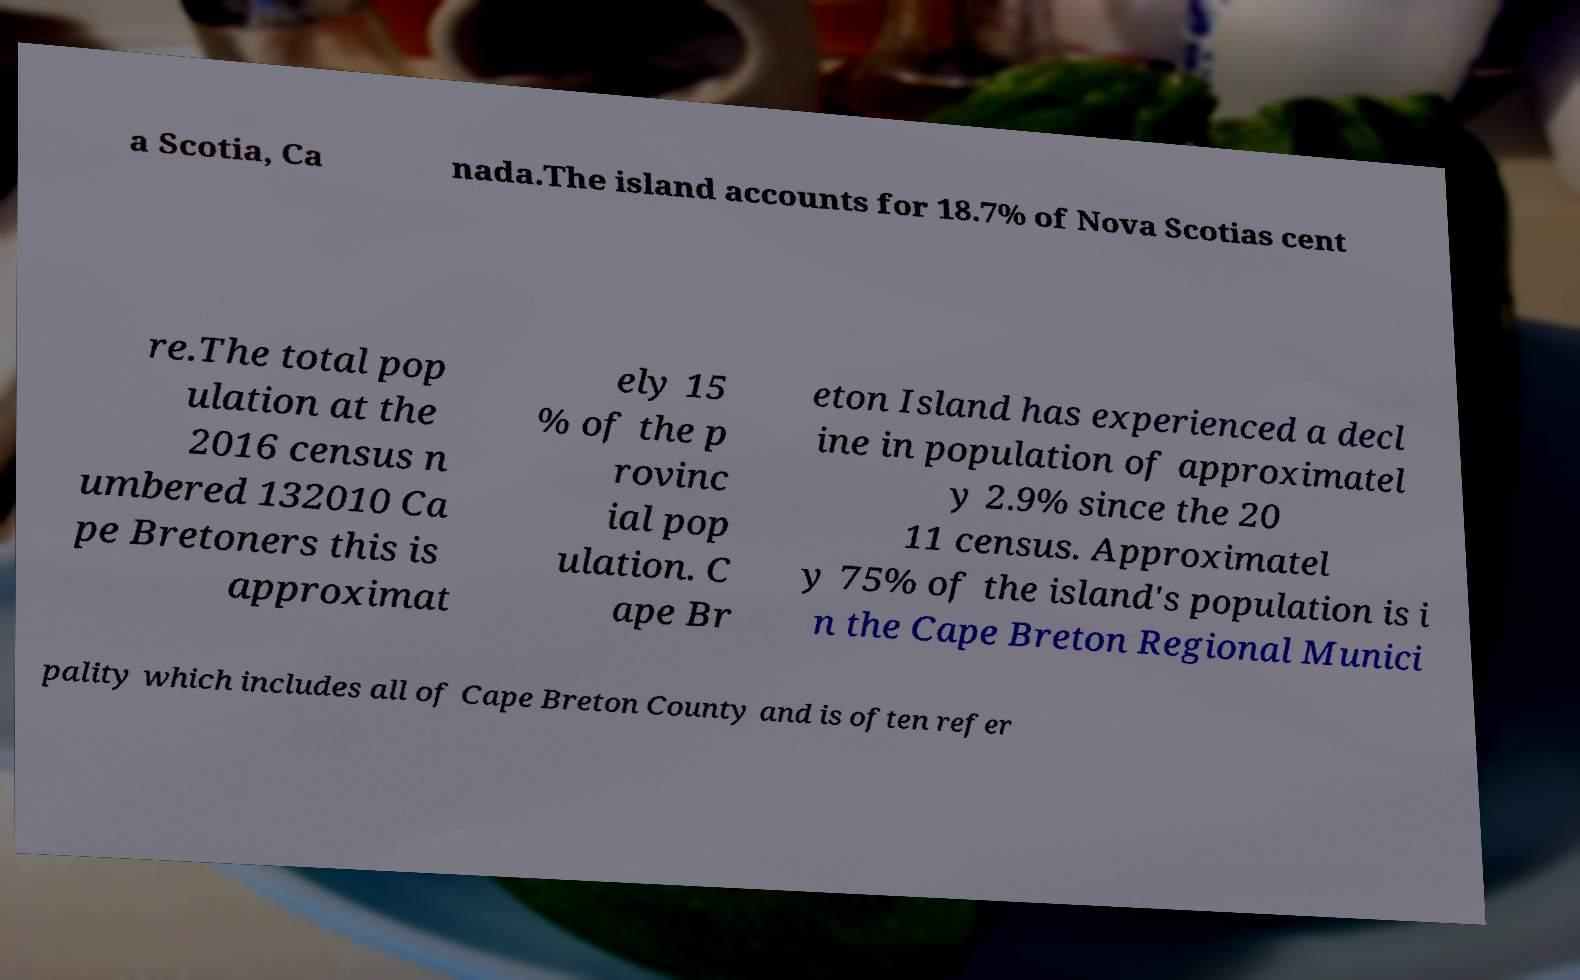Can you read and provide the text displayed in the image?This photo seems to have some interesting text. Can you extract and type it out for me? a Scotia, Ca nada.The island accounts for 18.7% of Nova Scotias cent re.The total pop ulation at the 2016 census n umbered 132010 Ca pe Bretoners this is approximat ely 15 % of the p rovinc ial pop ulation. C ape Br eton Island has experienced a decl ine in population of approximatel y 2.9% since the 20 11 census. Approximatel y 75% of the island's population is i n the Cape Breton Regional Munici pality which includes all of Cape Breton County and is often refer 